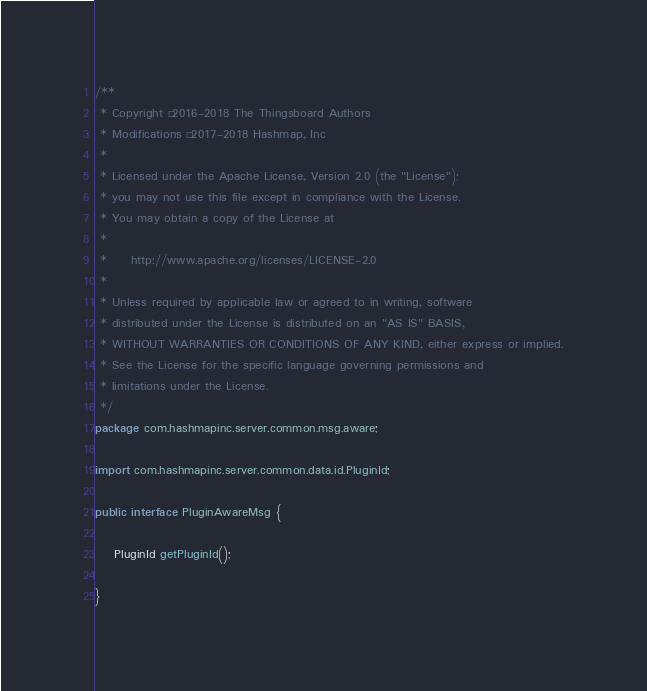<code> <loc_0><loc_0><loc_500><loc_500><_Java_>/**
 * Copyright © 2016-2018 The Thingsboard Authors
 * Modifications © 2017-2018 Hashmap, Inc
 *
 * Licensed under the Apache License, Version 2.0 (the "License");
 * you may not use this file except in compliance with the License.
 * You may obtain a copy of the License at
 *
 *     http://www.apache.org/licenses/LICENSE-2.0
 *
 * Unless required by applicable law or agreed to in writing, software
 * distributed under the License is distributed on an "AS IS" BASIS,
 * WITHOUT WARRANTIES OR CONDITIONS OF ANY KIND, either express or implied.
 * See the License for the specific language governing permissions and
 * limitations under the License.
 */
package com.hashmapinc.server.common.msg.aware;

import com.hashmapinc.server.common.data.id.PluginId;

public interface PluginAwareMsg {

    PluginId getPluginId();
    
}
</code> 